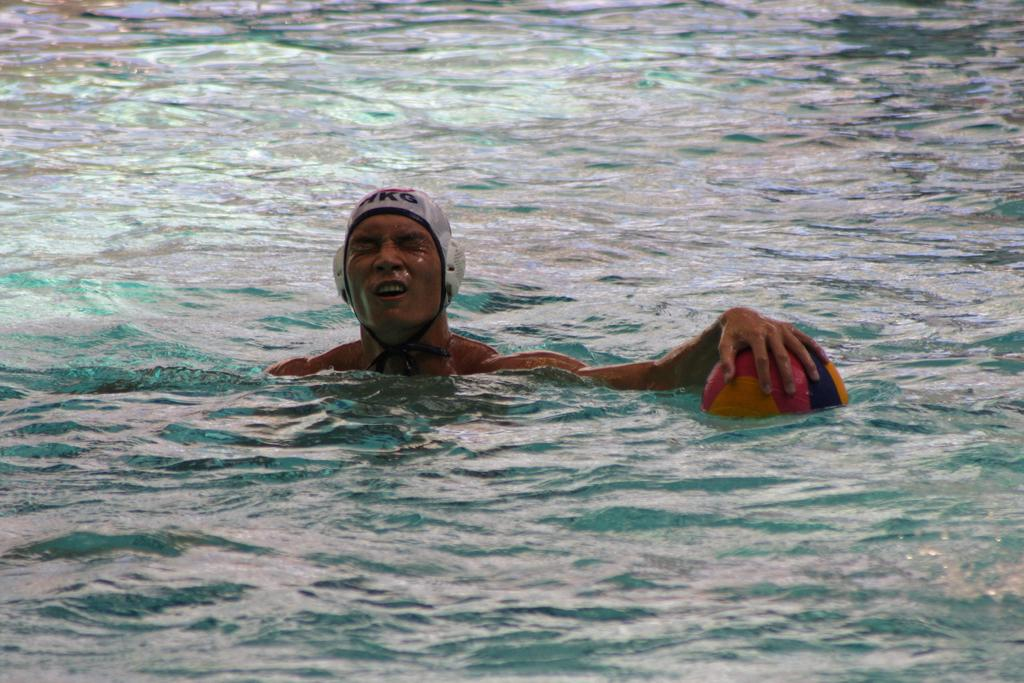Who is present in the image? There is a man in the image. Where is the man located? The man is in the water. What object can be seen in the image besides the man? There is a beach ball in the image. What is happening with the water in the image? Water is flowing in the image. What type of underwear is the man wearing in the image? There is no information about the man's underwear in the image, so it cannot be determined. 